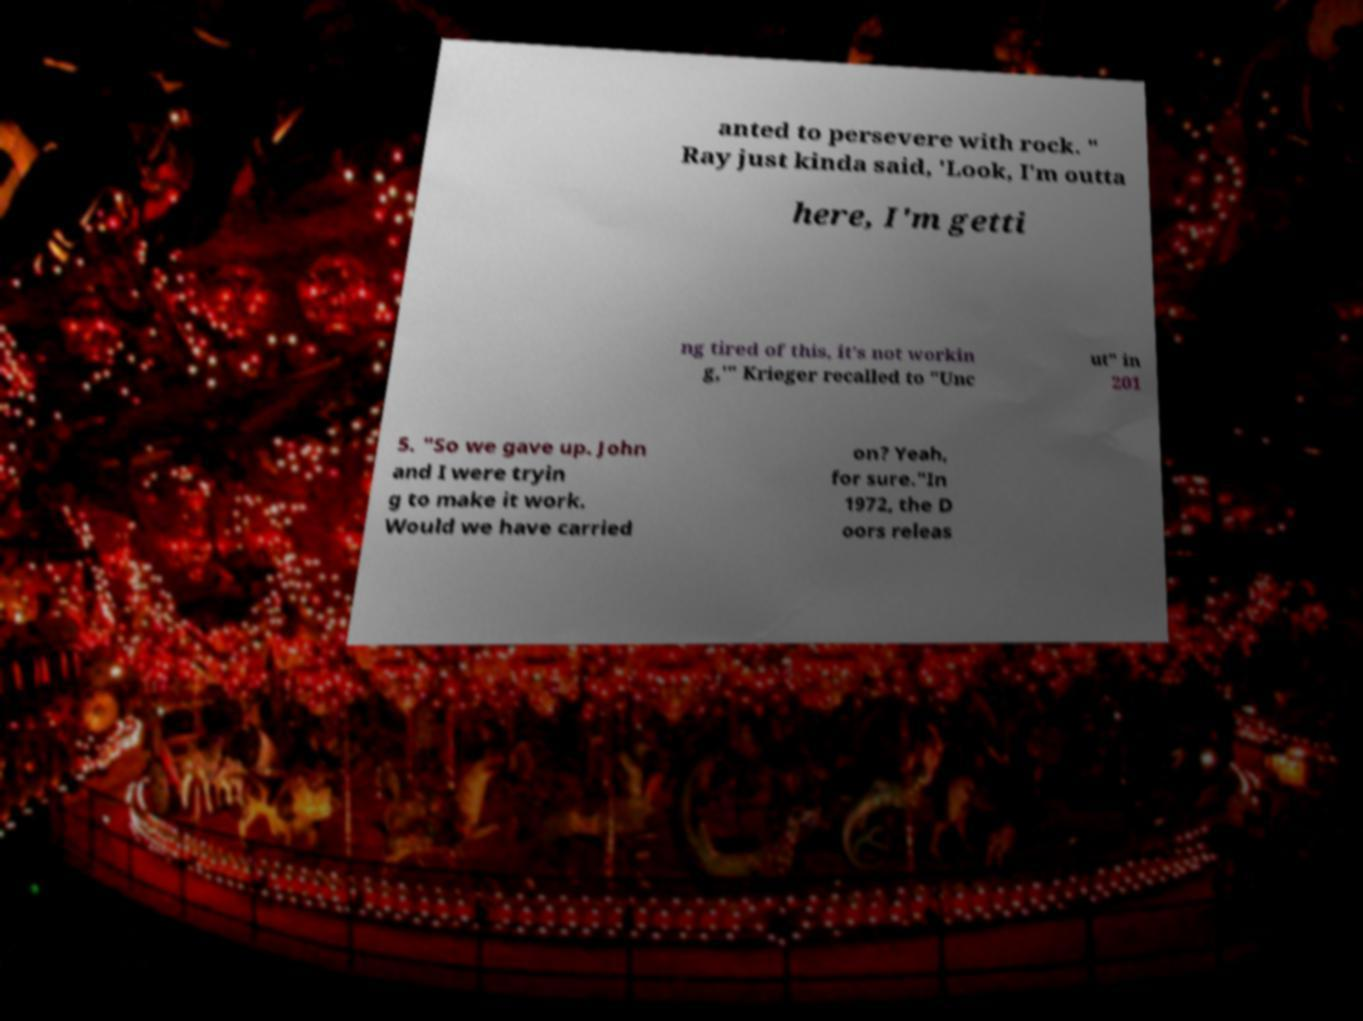For documentation purposes, I need the text within this image transcribed. Could you provide that? anted to persevere with rock. " Ray just kinda said, 'Look, I'm outta here, I'm getti ng tired of this, it's not workin g,'" Krieger recalled to "Unc ut" in 201 5. "So we gave up. John and I were tryin g to make it work. Would we have carried on? Yeah, for sure."In 1972, the D oors releas 